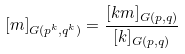Convert formula to latex. <formula><loc_0><loc_0><loc_500><loc_500>[ m ] _ { G ( p ^ { k } , q ^ { k } ) } = \frac { [ k m ] _ { G ( p , q ) } } { [ k ] _ { G ( p , q ) } }</formula> 